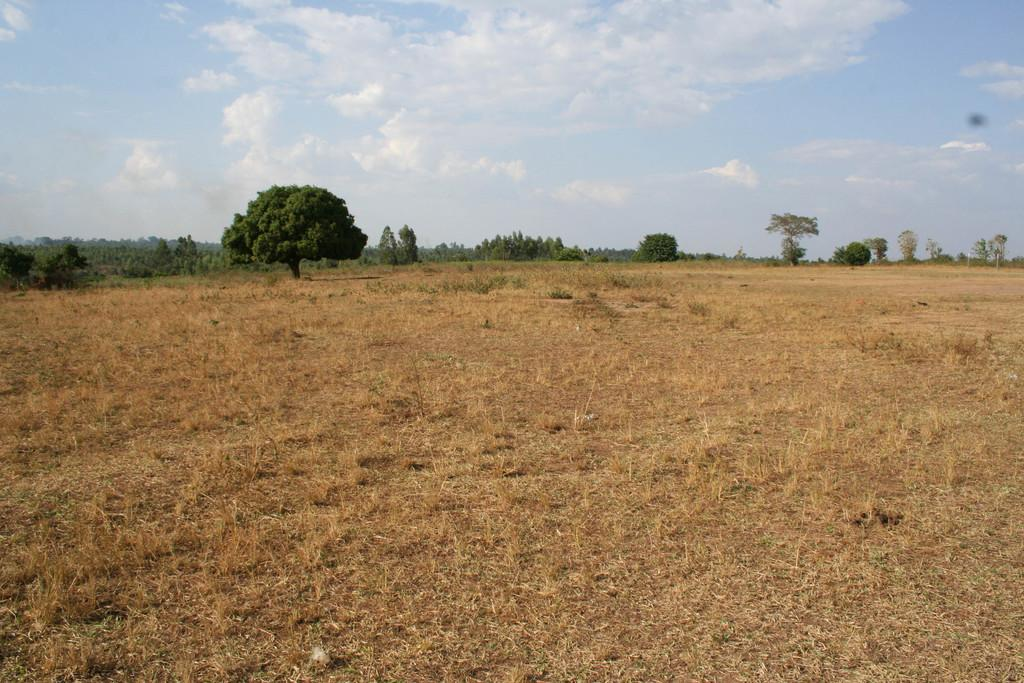What type of vegetation is on the ground in the image? There is dry grass on the ground in the image. What other natural elements can be seen in the image? There are trees in the image. What is visible in the background of the image? The sky is visible in the background of the image. What can be observed in the sky? Clouds are present in the sky. How many attempts were made to catch the net in the image? There is no net or attempt to catch it present in the image. 